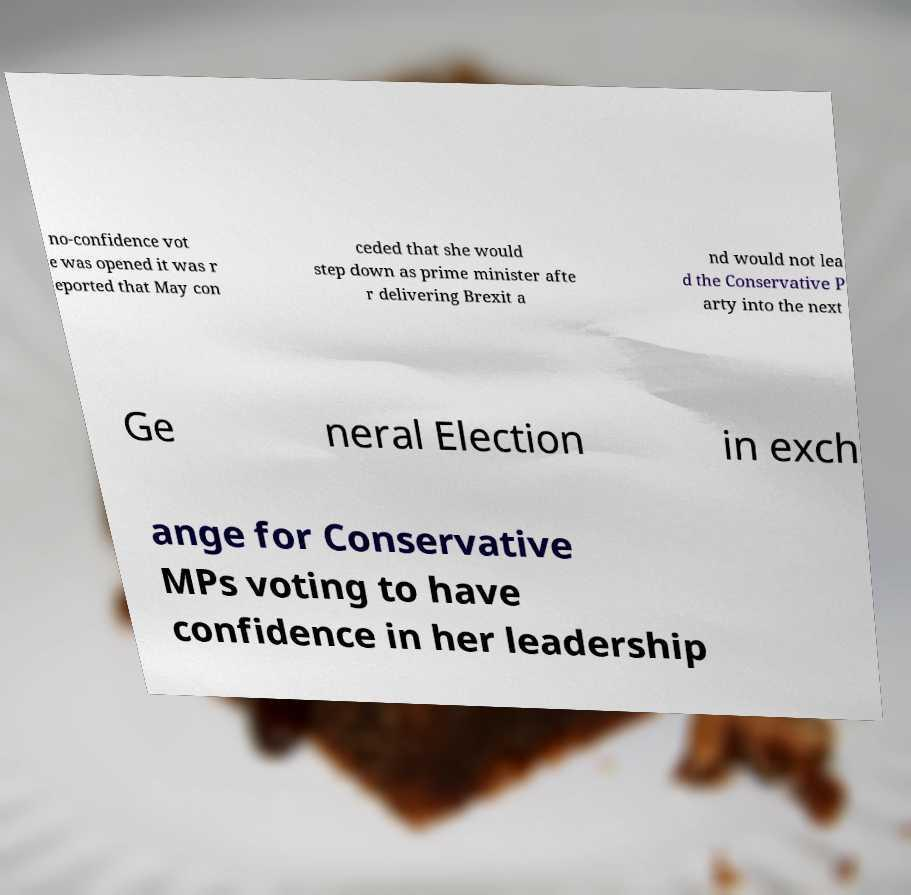Can you read and provide the text displayed in the image?This photo seems to have some interesting text. Can you extract and type it out for me? no-confidence vot e was opened it was r eported that May con ceded that she would step down as prime minister afte r delivering Brexit a nd would not lea d the Conservative P arty into the next Ge neral Election in exch ange for Conservative MPs voting to have confidence in her leadership 